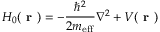Convert formula to latex. <formula><loc_0><loc_0><loc_500><loc_500>H _ { 0 } ( r ) = - \frac { \hbar { ^ } { 2 } } { 2 m _ { e f f } } \nabla ^ { 2 } + V ( r )</formula> 